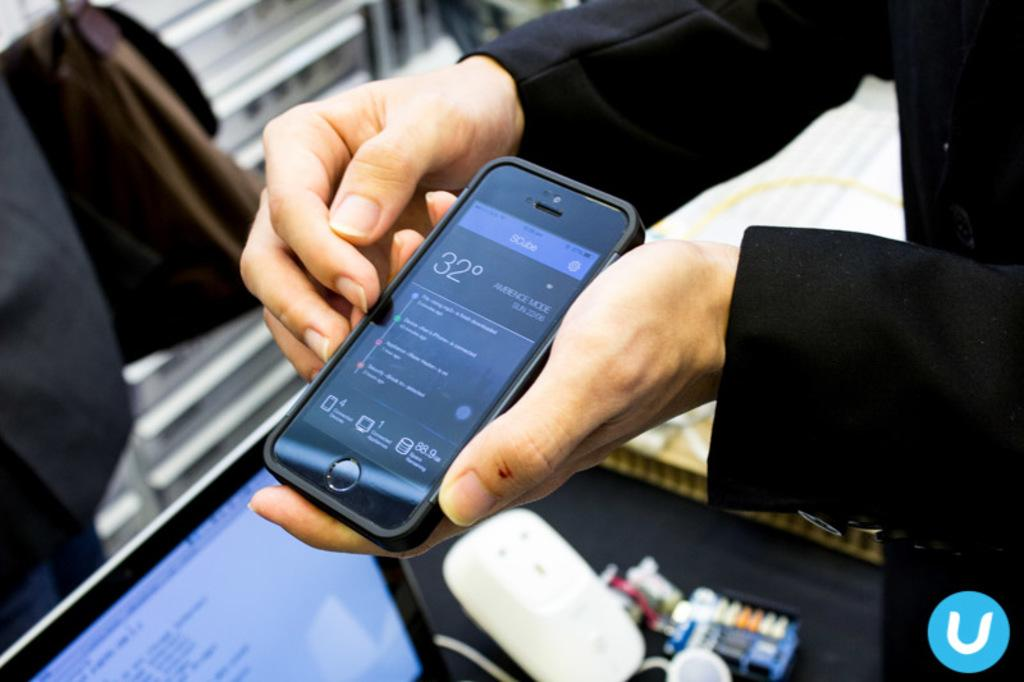Provide a one-sentence caption for the provided image. Person holding a smartphone that says 32 degrees outside. 